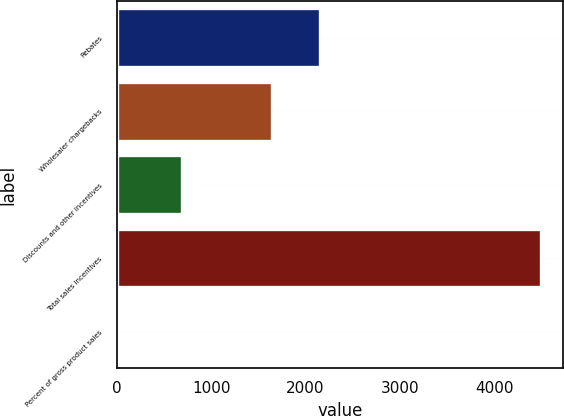Convert chart to OTSL. <chart><loc_0><loc_0><loc_500><loc_500><bar_chart><fcel>Rebates<fcel>Wholesaler chargebacks<fcel>Discounts and other incentives<fcel>Total sales incentives<fcel>Percent of gross product sales<nl><fcel>2156<fcel>1649<fcel>694<fcel>4499<fcel>24<nl></chart> 